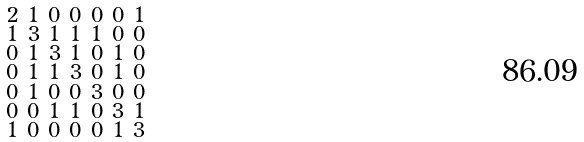<formula> <loc_0><loc_0><loc_500><loc_500>\begin{smallmatrix} 2 & 1 & 0 & 0 & 0 & 0 & 1 \\ 1 & 3 & 1 & 1 & 1 & 0 & 0 \\ 0 & 1 & 3 & 1 & 0 & 1 & 0 \\ 0 & 1 & 1 & 3 & 0 & 1 & 0 \\ 0 & 1 & 0 & 0 & 3 & 0 & 0 \\ 0 & 0 & 1 & 1 & 0 & 3 & 1 \\ 1 & 0 & 0 & 0 & 0 & 1 & 3 \end{smallmatrix}</formula> 